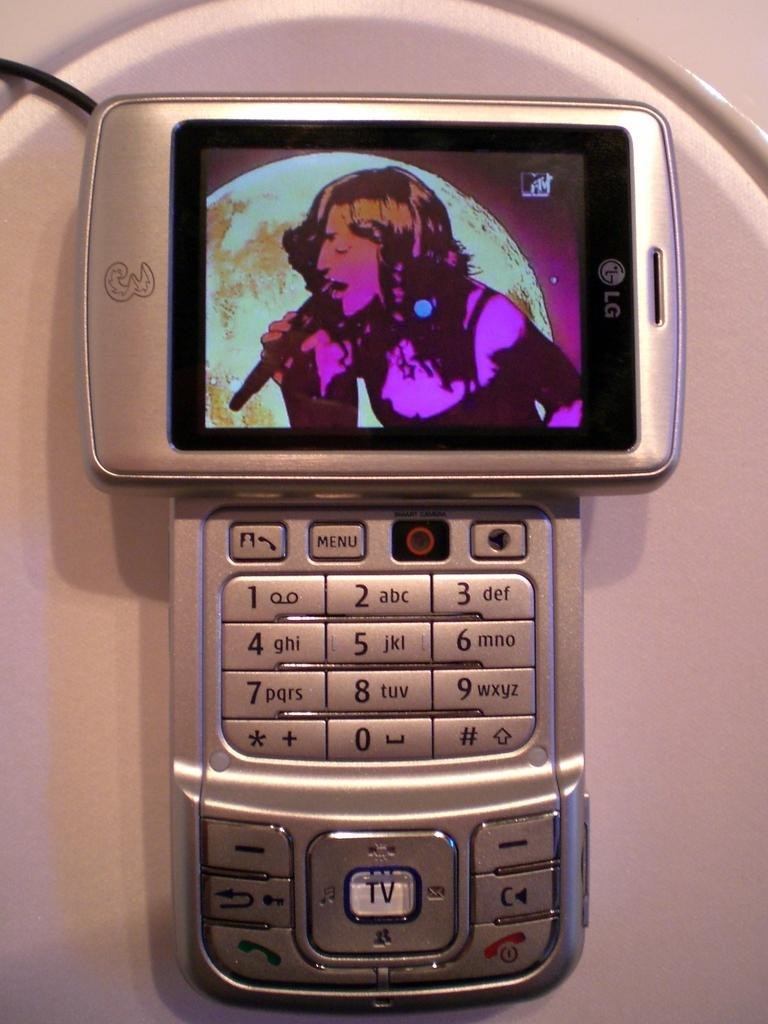<image>
Give a short and clear explanation of the subsequent image. LG cell phone that is silver and black with a mtv logo on the home screen. 